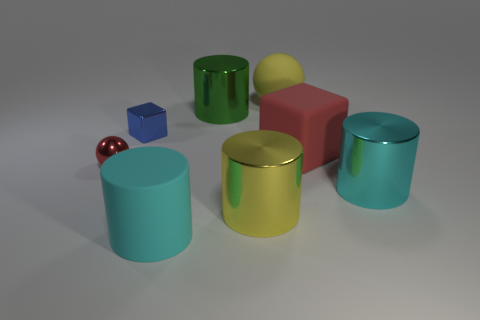Subtract all cyan cylinders. How many were subtracted if there are1cyan cylinders left? 1 Subtract all gray cylinders. Subtract all cyan blocks. How many cylinders are left? 4 Add 1 big yellow matte spheres. How many objects exist? 9 Subtract all balls. How many objects are left? 6 Add 7 big matte spheres. How many big matte spheres exist? 8 Subtract 0 gray balls. How many objects are left? 8 Subtract all tiny objects. Subtract all matte cylinders. How many objects are left? 5 Add 1 large red objects. How many large red objects are left? 2 